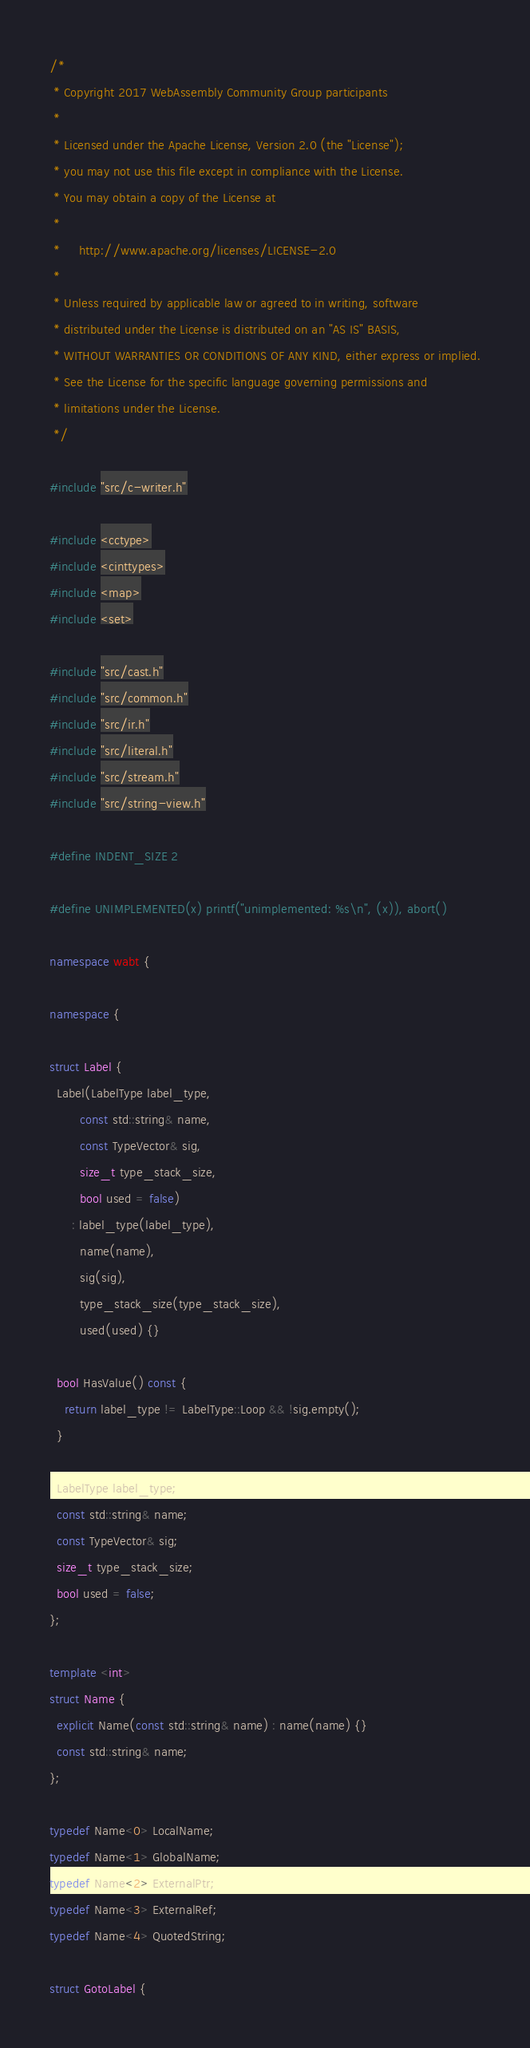Convert code to text. <code><loc_0><loc_0><loc_500><loc_500><_C++_>/*
 * Copyright 2017 WebAssembly Community Group participants
 *
 * Licensed under the Apache License, Version 2.0 (the "License");
 * you may not use this file except in compliance with the License.
 * You may obtain a copy of the License at
 *
 *     http://www.apache.org/licenses/LICENSE-2.0
 *
 * Unless required by applicable law or agreed to in writing, software
 * distributed under the License is distributed on an "AS IS" BASIS,
 * WITHOUT WARRANTIES OR CONDITIONS OF ANY KIND, either express or implied.
 * See the License for the specific language governing permissions and
 * limitations under the License.
 */

#include "src/c-writer.h"

#include <cctype>
#include <cinttypes>
#include <map>
#include <set>

#include "src/cast.h"
#include "src/common.h"
#include "src/ir.h"
#include "src/literal.h"
#include "src/stream.h"
#include "src/string-view.h"

#define INDENT_SIZE 2

#define UNIMPLEMENTED(x) printf("unimplemented: %s\n", (x)), abort()

namespace wabt {

namespace {

struct Label {
  Label(LabelType label_type,
        const std::string& name,
        const TypeVector& sig,
        size_t type_stack_size,
        bool used = false)
      : label_type(label_type),
        name(name),
        sig(sig),
        type_stack_size(type_stack_size),
        used(used) {}

  bool HasValue() const {
    return label_type != LabelType::Loop && !sig.empty();
  }

  LabelType label_type;
  const std::string& name;
  const TypeVector& sig;
  size_t type_stack_size;
  bool used = false;
};

template <int>
struct Name {
  explicit Name(const std::string& name) : name(name) {}
  const std::string& name;
};

typedef Name<0> LocalName;
typedef Name<1> GlobalName;
typedef Name<2> ExternalPtr;
typedef Name<3> ExternalRef;
typedef Name<4> QuotedString;

struct GotoLabel {</code> 